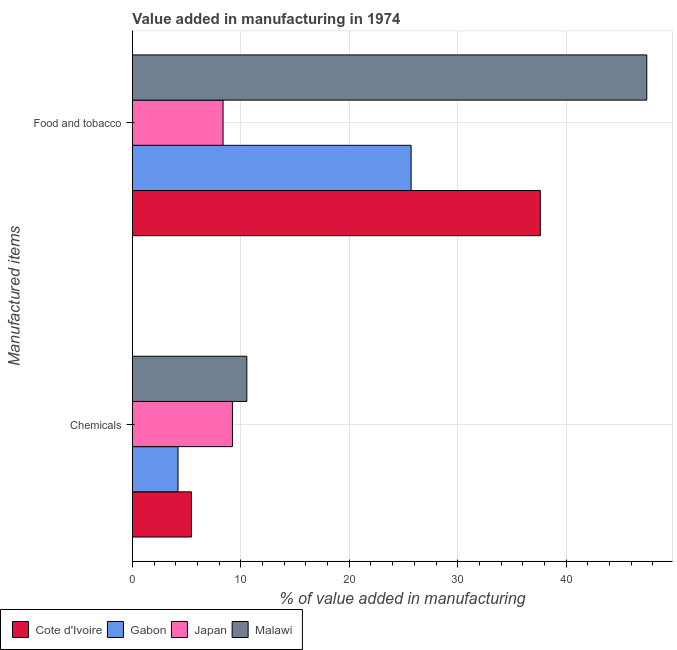How many different coloured bars are there?
Keep it short and to the point. 4. Are the number of bars per tick equal to the number of legend labels?
Make the answer very short. Yes. Are the number of bars on each tick of the Y-axis equal?
Make the answer very short. Yes. How many bars are there on the 1st tick from the top?
Your answer should be very brief. 4. What is the label of the 1st group of bars from the top?
Offer a very short reply. Food and tobacco. What is the value added by  manufacturing chemicals in Cote d'Ivoire?
Provide a succinct answer. 5.44. Across all countries, what is the maximum value added by manufacturing food and tobacco?
Provide a short and direct response. 47.44. Across all countries, what is the minimum value added by manufacturing food and tobacco?
Offer a very short reply. 8.36. In which country was the value added by  manufacturing chemicals maximum?
Ensure brevity in your answer.  Malawi. In which country was the value added by  manufacturing chemicals minimum?
Your answer should be compact. Gabon. What is the total value added by manufacturing food and tobacco in the graph?
Make the answer very short. 119.11. What is the difference between the value added by manufacturing food and tobacco in Gabon and that in Cote d'Ivoire?
Offer a very short reply. -11.92. What is the difference between the value added by manufacturing food and tobacco in Gabon and the value added by  manufacturing chemicals in Malawi?
Provide a succinct answer. 15.15. What is the average value added by  manufacturing chemicals per country?
Provide a succinct answer. 7.35. What is the difference between the value added by manufacturing food and tobacco and value added by  manufacturing chemicals in Cote d'Ivoire?
Make the answer very short. 32.18. In how many countries, is the value added by  manufacturing chemicals greater than 32 %?
Keep it short and to the point. 0. What is the ratio of the value added by manufacturing food and tobacco in Gabon to that in Cote d'Ivoire?
Provide a short and direct response. 0.68. Is the value added by manufacturing food and tobacco in Malawi less than that in Cote d'Ivoire?
Give a very brief answer. No. What does the 2nd bar from the top in Food and tobacco represents?
Your answer should be compact. Japan. What does the 1st bar from the bottom in Food and tobacco represents?
Your answer should be compact. Cote d'Ivoire. How many bars are there?
Offer a terse response. 8. Are all the bars in the graph horizontal?
Your response must be concise. Yes. Are the values on the major ticks of X-axis written in scientific E-notation?
Give a very brief answer. No. Where does the legend appear in the graph?
Ensure brevity in your answer.  Bottom left. How many legend labels are there?
Your answer should be compact. 4. What is the title of the graph?
Ensure brevity in your answer.  Value added in manufacturing in 1974. Does "Georgia" appear as one of the legend labels in the graph?
Your answer should be compact. No. What is the label or title of the X-axis?
Your response must be concise. % of value added in manufacturing. What is the label or title of the Y-axis?
Provide a succinct answer. Manufactured items. What is the % of value added in manufacturing of Cote d'Ivoire in Chemicals?
Provide a short and direct response. 5.44. What is the % of value added in manufacturing in Gabon in Chemicals?
Provide a short and direct response. 4.2. What is the % of value added in manufacturing in Japan in Chemicals?
Your answer should be very brief. 9.22. What is the % of value added in manufacturing in Malawi in Chemicals?
Your response must be concise. 10.55. What is the % of value added in manufacturing in Cote d'Ivoire in Food and tobacco?
Provide a short and direct response. 37.62. What is the % of value added in manufacturing of Gabon in Food and tobacco?
Offer a terse response. 25.7. What is the % of value added in manufacturing of Japan in Food and tobacco?
Your response must be concise. 8.36. What is the % of value added in manufacturing in Malawi in Food and tobacco?
Make the answer very short. 47.44. Across all Manufactured items, what is the maximum % of value added in manufacturing of Cote d'Ivoire?
Your answer should be compact. 37.62. Across all Manufactured items, what is the maximum % of value added in manufacturing in Gabon?
Your answer should be very brief. 25.7. Across all Manufactured items, what is the maximum % of value added in manufacturing of Japan?
Your response must be concise. 9.22. Across all Manufactured items, what is the maximum % of value added in manufacturing in Malawi?
Provide a short and direct response. 47.44. Across all Manufactured items, what is the minimum % of value added in manufacturing of Cote d'Ivoire?
Give a very brief answer. 5.44. Across all Manufactured items, what is the minimum % of value added in manufacturing in Gabon?
Your answer should be compact. 4.2. Across all Manufactured items, what is the minimum % of value added in manufacturing of Japan?
Your response must be concise. 8.36. Across all Manufactured items, what is the minimum % of value added in manufacturing of Malawi?
Make the answer very short. 10.55. What is the total % of value added in manufacturing of Cote d'Ivoire in the graph?
Give a very brief answer. 43.06. What is the total % of value added in manufacturing in Gabon in the graph?
Provide a short and direct response. 29.9. What is the total % of value added in manufacturing in Japan in the graph?
Your answer should be compact. 17.58. What is the total % of value added in manufacturing in Malawi in the graph?
Provide a succinct answer. 57.99. What is the difference between the % of value added in manufacturing of Cote d'Ivoire in Chemicals and that in Food and tobacco?
Your answer should be compact. -32.18. What is the difference between the % of value added in manufacturing in Gabon in Chemicals and that in Food and tobacco?
Offer a very short reply. -21.5. What is the difference between the % of value added in manufacturing in Japan in Chemicals and that in Food and tobacco?
Provide a succinct answer. 0.86. What is the difference between the % of value added in manufacturing of Malawi in Chemicals and that in Food and tobacco?
Offer a terse response. -36.89. What is the difference between the % of value added in manufacturing of Cote d'Ivoire in Chemicals and the % of value added in manufacturing of Gabon in Food and tobacco?
Make the answer very short. -20.26. What is the difference between the % of value added in manufacturing of Cote d'Ivoire in Chemicals and the % of value added in manufacturing of Japan in Food and tobacco?
Give a very brief answer. -2.92. What is the difference between the % of value added in manufacturing in Cote d'Ivoire in Chemicals and the % of value added in manufacturing in Malawi in Food and tobacco?
Offer a terse response. -41.99. What is the difference between the % of value added in manufacturing in Gabon in Chemicals and the % of value added in manufacturing in Japan in Food and tobacco?
Give a very brief answer. -4.16. What is the difference between the % of value added in manufacturing in Gabon in Chemicals and the % of value added in manufacturing in Malawi in Food and tobacco?
Offer a very short reply. -43.23. What is the difference between the % of value added in manufacturing in Japan in Chemicals and the % of value added in manufacturing in Malawi in Food and tobacco?
Offer a very short reply. -38.21. What is the average % of value added in manufacturing of Cote d'Ivoire per Manufactured items?
Offer a terse response. 21.53. What is the average % of value added in manufacturing of Gabon per Manufactured items?
Keep it short and to the point. 14.95. What is the average % of value added in manufacturing of Japan per Manufactured items?
Ensure brevity in your answer.  8.79. What is the average % of value added in manufacturing in Malawi per Manufactured items?
Ensure brevity in your answer.  28.99. What is the difference between the % of value added in manufacturing in Cote d'Ivoire and % of value added in manufacturing in Gabon in Chemicals?
Ensure brevity in your answer.  1.24. What is the difference between the % of value added in manufacturing in Cote d'Ivoire and % of value added in manufacturing in Japan in Chemicals?
Offer a very short reply. -3.78. What is the difference between the % of value added in manufacturing of Cote d'Ivoire and % of value added in manufacturing of Malawi in Chemicals?
Ensure brevity in your answer.  -5.11. What is the difference between the % of value added in manufacturing in Gabon and % of value added in manufacturing in Japan in Chemicals?
Provide a succinct answer. -5.02. What is the difference between the % of value added in manufacturing in Gabon and % of value added in manufacturing in Malawi in Chemicals?
Your response must be concise. -6.35. What is the difference between the % of value added in manufacturing in Japan and % of value added in manufacturing in Malawi in Chemicals?
Ensure brevity in your answer.  -1.33. What is the difference between the % of value added in manufacturing in Cote d'Ivoire and % of value added in manufacturing in Gabon in Food and tobacco?
Your answer should be very brief. 11.92. What is the difference between the % of value added in manufacturing in Cote d'Ivoire and % of value added in manufacturing in Japan in Food and tobacco?
Provide a succinct answer. 29.26. What is the difference between the % of value added in manufacturing of Cote d'Ivoire and % of value added in manufacturing of Malawi in Food and tobacco?
Make the answer very short. -9.82. What is the difference between the % of value added in manufacturing of Gabon and % of value added in manufacturing of Japan in Food and tobacco?
Make the answer very short. 17.34. What is the difference between the % of value added in manufacturing in Gabon and % of value added in manufacturing in Malawi in Food and tobacco?
Ensure brevity in your answer.  -21.73. What is the difference between the % of value added in manufacturing in Japan and % of value added in manufacturing in Malawi in Food and tobacco?
Offer a terse response. -39.08. What is the ratio of the % of value added in manufacturing in Cote d'Ivoire in Chemicals to that in Food and tobacco?
Your answer should be very brief. 0.14. What is the ratio of the % of value added in manufacturing in Gabon in Chemicals to that in Food and tobacco?
Provide a short and direct response. 0.16. What is the ratio of the % of value added in manufacturing of Japan in Chemicals to that in Food and tobacco?
Make the answer very short. 1.1. What is the ratio of the % of value added in manufacturing of Malawi in Chemicals to that in Food and tobacco?
Your answer should be compact. 0.22. What is the difference between the highest and the second highest % of value added in manufacturing in Cote d'Ivoire?
Keep it short and to the point. 32.18. What is the difference between the highest and the second highest % of value added in manufacturing in Gabon?
Keep it short and to the point. 21.5. What is the difference between the highest and the second highest % of value added in manufacturing in Japan?
Offer a terse response. 0.86. What is the difference between the highest and the second highest % of value added in manufacturing of Malawi?
Your answer should be very brief. 36.89. What is the difference between the highest and the lowest % of value added in manufacturing of Cote d'Ivoire?
Provide a short and direct response. 32.18. What is the difference between the highest and the lowest % of value added in manufacturing of Gabon?
Make the answer very short. 21.5. What is the difference between the highest and the lowest % of value added in manufacturing of Japan?
Offer a very short reply. 0.86. What is the difference between the highest and the lowest % of value added in manufacturing of Malawi?
Offer a terse response. 36.89. 